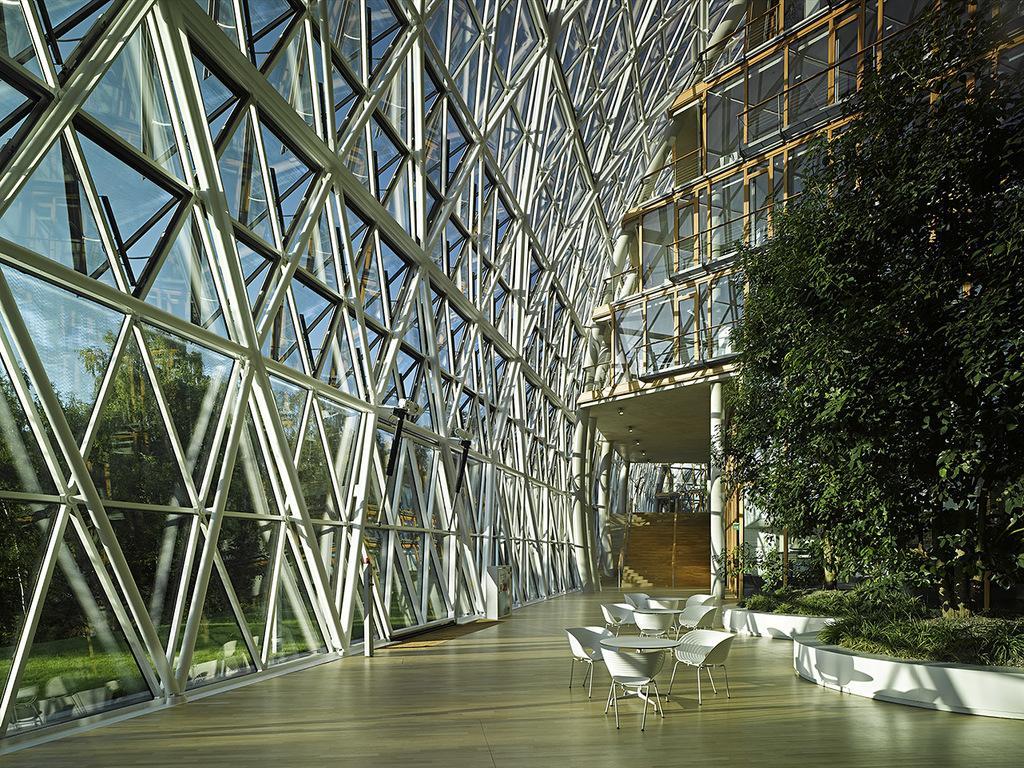Describe this image in one or two sentences. In this image, we can see building and in the background, there are trees and here we can see tables and chairs. 